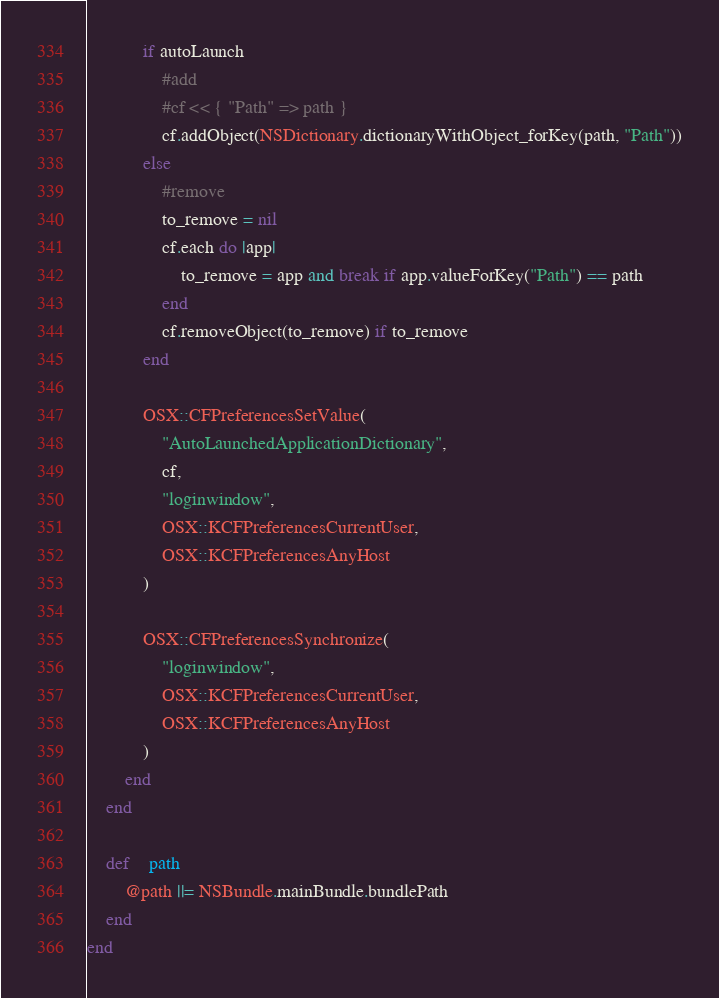<code> <loc_0><loc_0><loc_500><loc_500><_Ruby_>			if autoLaunch
				#add
				#cf << { "Path" => path }
				cf.addObject(NSDictionary.dictionaryWithObject_forKey(path, "Path"))
			else
				#remove
				to_remove = nil
				cf.each do |app|
					to_remove = app and break if app.valueForKey("Path") == path
				end
				cf.removeObject(to_remove) if to_remove
			end
			
			OSX::CFPreferencesSetValue(
				"AutoLaunchedApplicationDictionary",
				cf,
				"loginwindow",
				OSX::KCFPreferencesCurrentUser,
				OSX::KCFPreferencesAnyHost
			)
			
			OSX::CFPreferencesSynchronize(
				"loginwindow",
				OSX::KCFPreferencesCurrentUser,
				OSX::KCFPreferencesAnyHost
			)
		end
	end
	
	def	path
		@path ||= NSBundle.mainBundle.bundlePath
	end
end
</code> 